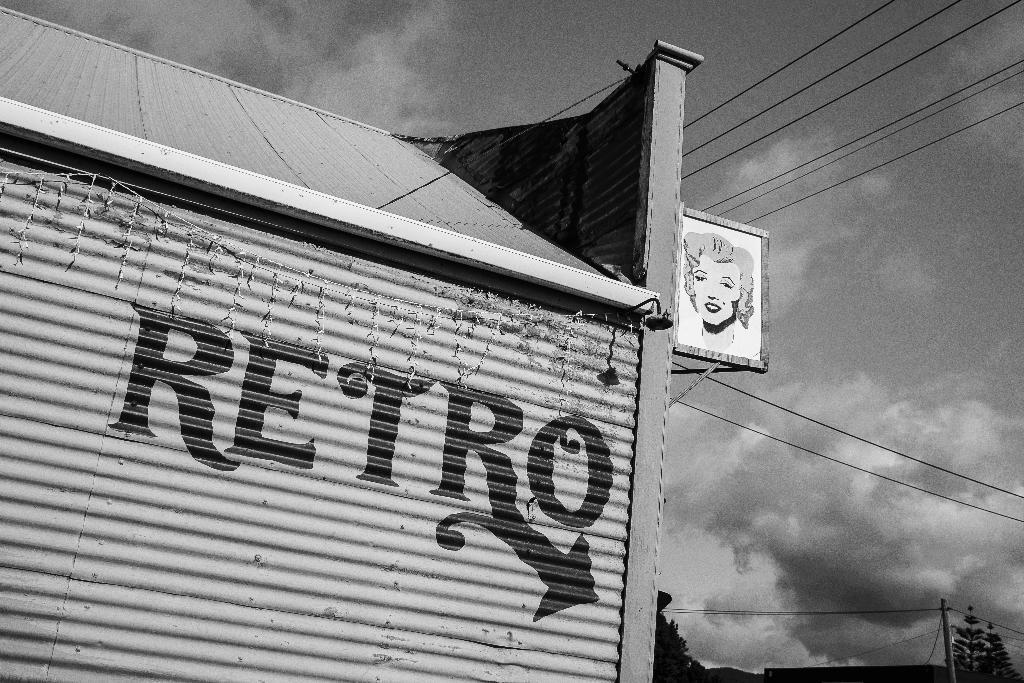Please provide a concise description of this image. This picture is in black and white. In this picture, we see a building. Beside that, we see a white color board containing the sketch of the girl. At the bottom of the picture, we see trees, electric pole and wires. At the top of the picture, we see the sky and the wires. 